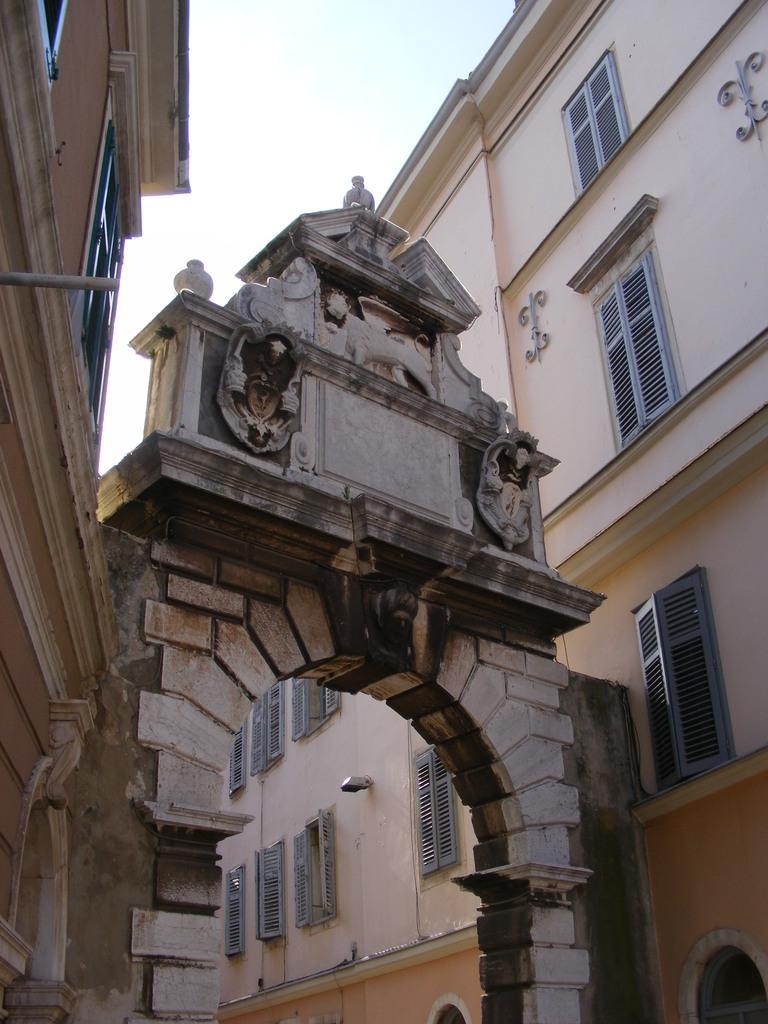Please provide a concise description of this image. In this picture I can see buildings, a arch and I can see cloudy sky. 